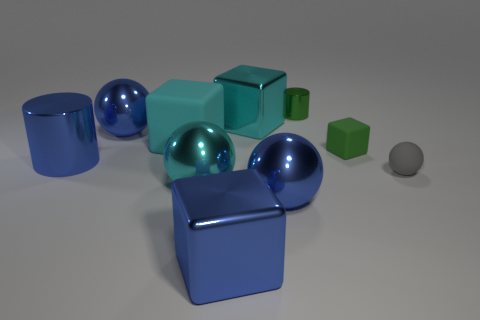Subtract 1 spheres. How many spheres are left? 3 Subtract all purple cylinders. Subtract all blue blocks. How many cylinders are left? 2 Subtract all cubes. How many objects are left? 6 Subtract all big cyan objects. Subtract all big cyan matte things. How many objects are left? 6 Add 1 small green cubes. How many small green cubes are left? 2 Add 3 large yellow metal spheres. How many large yellow metal spheres exist? 3 Subtract 0 purple cylinders. How many objects are left? 10 